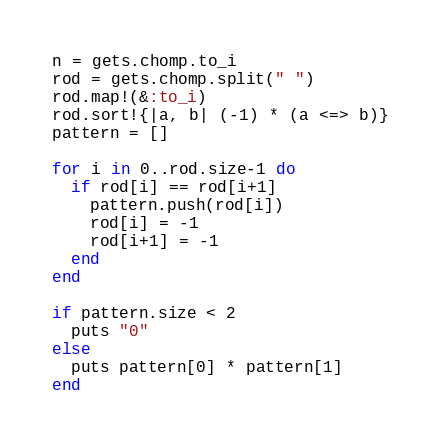Convert code to text. <code><loc_0><loc_0><loc_500><loc_500><_Ruby_>n = gets.chomp.to_i
rod = gets.chomp.split(" ")
rod.map!(&:to_i)
rod.sort!{|a, b| (-1) * (a <=> b)}
pattern = []

for i in 0..rod.size-1 do
  if rod[i] == rod[i+1]
    pattern.push(rod[i])
    rod[i] = -1
    rod[i+1] = -1
  end
end

if pattern.size < 2
  puts "0"
else
  puts pattern[0] * pattern[1]
end
</code> 